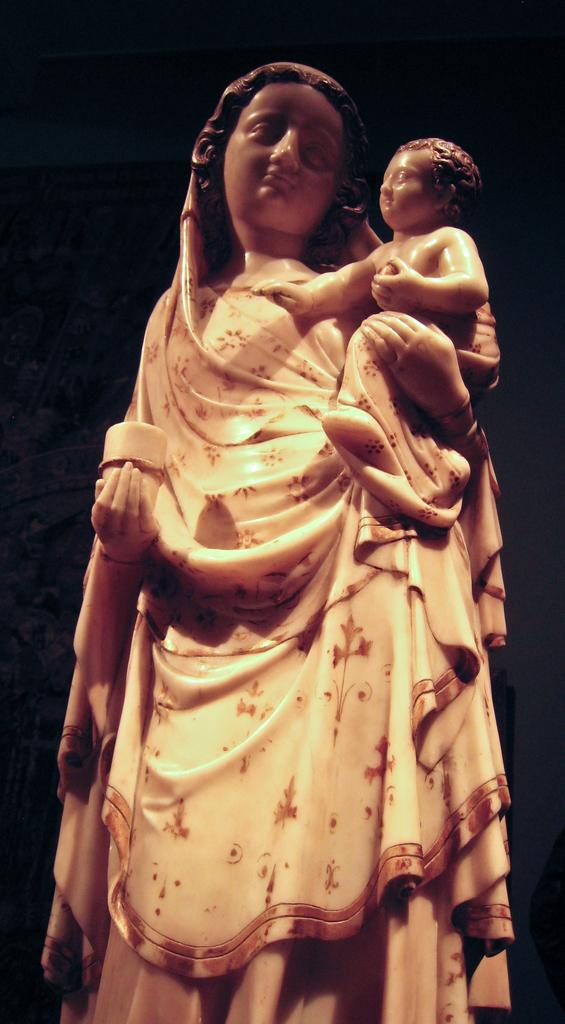What is the main subject of the image? The main subject of the image is a statue of a woman. What is the woman holding in her hand? The woman is holding a baby statue with one hand and an object with her other hand. What can be observed about the background of the image? The background of the image is dark in color. What type of lipstick is the woman wearing in the image? There is no lipstick or any indication of makeup on the woman in the image, as it is a statue. 